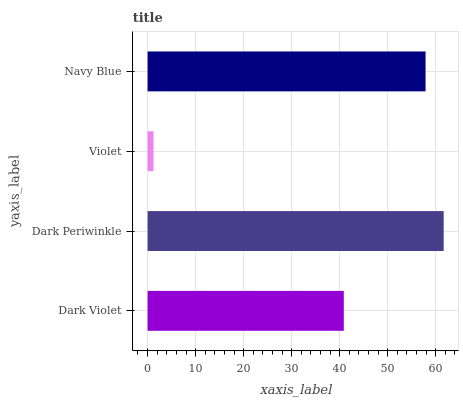Is Violet the minimum?
Answer yes or no. Yes. Is Dark Periwinkle the maximum?
Answer yes or no. Yes. Is Dark Periwinkle the minimum?
Answer yes or no. No. Is Violet the maximum?
Answer yes or no. No. Is Dark Periwinkle greater than Violet?
Answer yes or no. Yes. Is Violet less than Dark Periwinkle?
Answer yes or no. Yes. Is Violet greater than Dark Periwinkle?
Answer yes or no. No. Is Dark Periwinkle less than Violet?
Answer yes or no. No. Is Navy Blue the high median?
Answer yes or no. Yes. Is Dark Violet the low median?
Answer yes or no. Yes. Is Dark Violet the high median?
Answer yes or no. No. Is Navy Blue the low median?
Answer yes or no. No. 